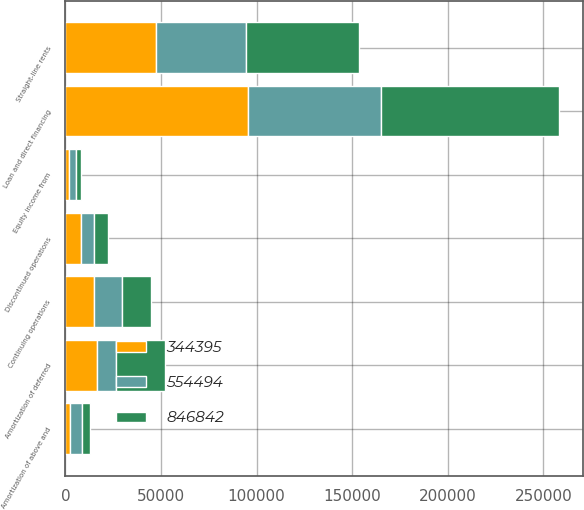Convert chart to OTSL. <chart><loc_0><loc_0><loc_500><loc_500><stacked_bar_chart><ecel><fcel>Continuing operations<fcel>Discontinued operations<fcel>Amortization of above and<fcel>Amortization of deferred<fcel>Straight-line rents<fcel>Loan and direct financing<fcel>Equity income from<nl><fcel>344395<fcel>14924<fcel>8267<fcel>2232<fcel>16501<fcel>47311<fcel>95444<fcel>1655<nl><fcel>846842<fcel>14924<fcel>7473<fcel>4510<fcel>25769<fcel>59173<fcel>93003<fcel>2319<nl><fcel>554494<fcel>14924<fcel>6513<fcel>6378<fcel>9856<fcel>47243<fcel>69645<fcel>3984<nl></chart> 